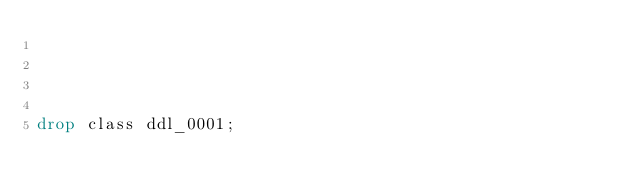Convert code to text. <code><loc_0><loc_0><loc_500><loc_500><_SQL_>



drop class ddl_0001;</code> 